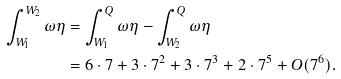<formula> <loc_0><loc_0><loc_500><loc_500>\int _ { W _ { 1 } } ^ { W _ { 2 } } \omega \eta & = \int _ { W _ { 1 } } ^ { Q } \omega \eta - \int _ { W _ { 2 } } ^ { Q } \omega \eta \\ & = 6 \cdot 7 + 3 \cdot 7 ^ { 2 } + 3 \cdot 7 ^ { 3 } + 2 \cdot 7 ^ { 5 } + O ( 7 ^ { 6 } ) .</formula> 